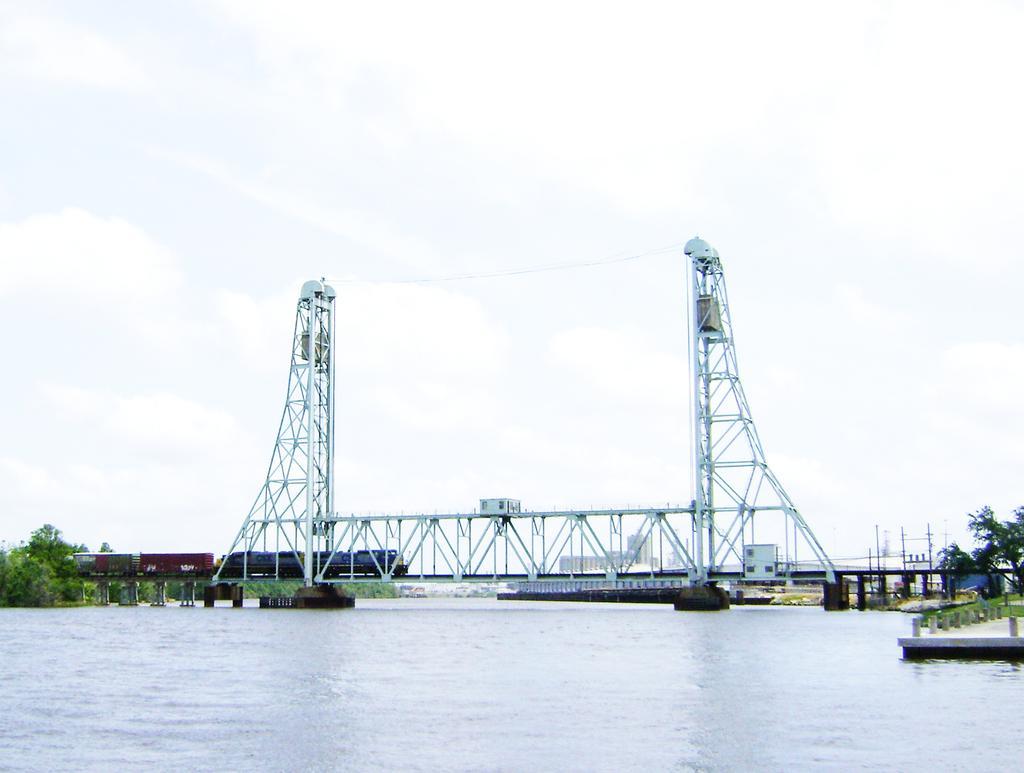Please provide a concise description of this image. In this image we can see one river, two boats in the river, one bridge with big barrier, two towers in the bridge, one object on the barrier, some pillars in the water, some poles on the ground, one railway track on the bridge, some concrete poles, some buildings, one train on the railway track, some objects on the ground, some trees, bushes, plants and grass on the ground. At the top there is the sky. 